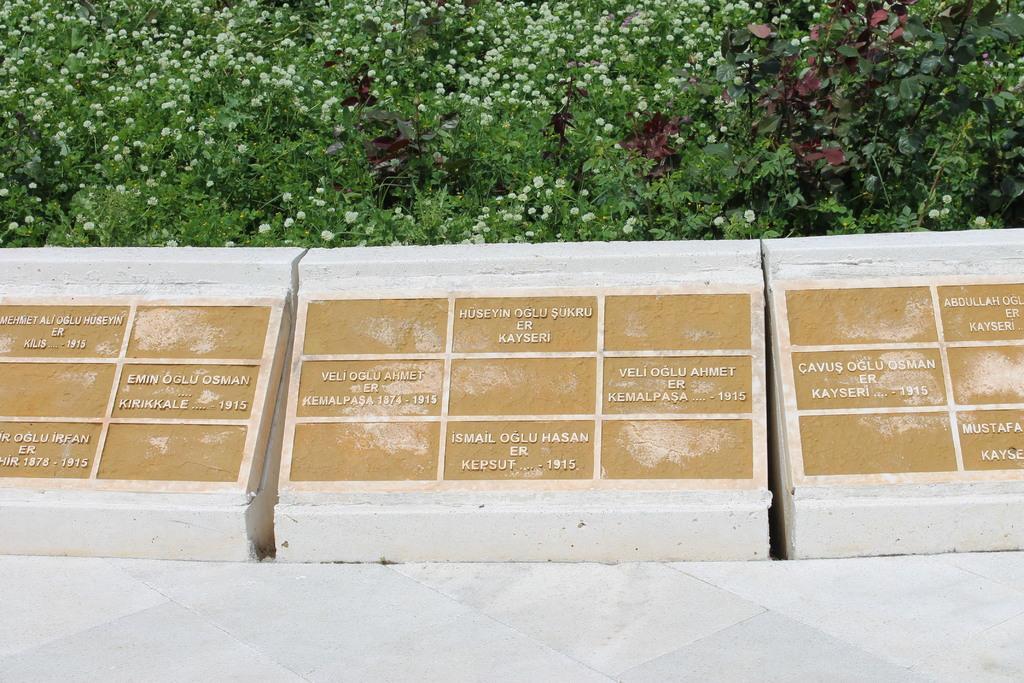Can you describe this image briefly? In this image, I can see the letters carved on the stones. In the background, there are plants with the tiny flowers. At the bottom of the image, It looks like a floor. 